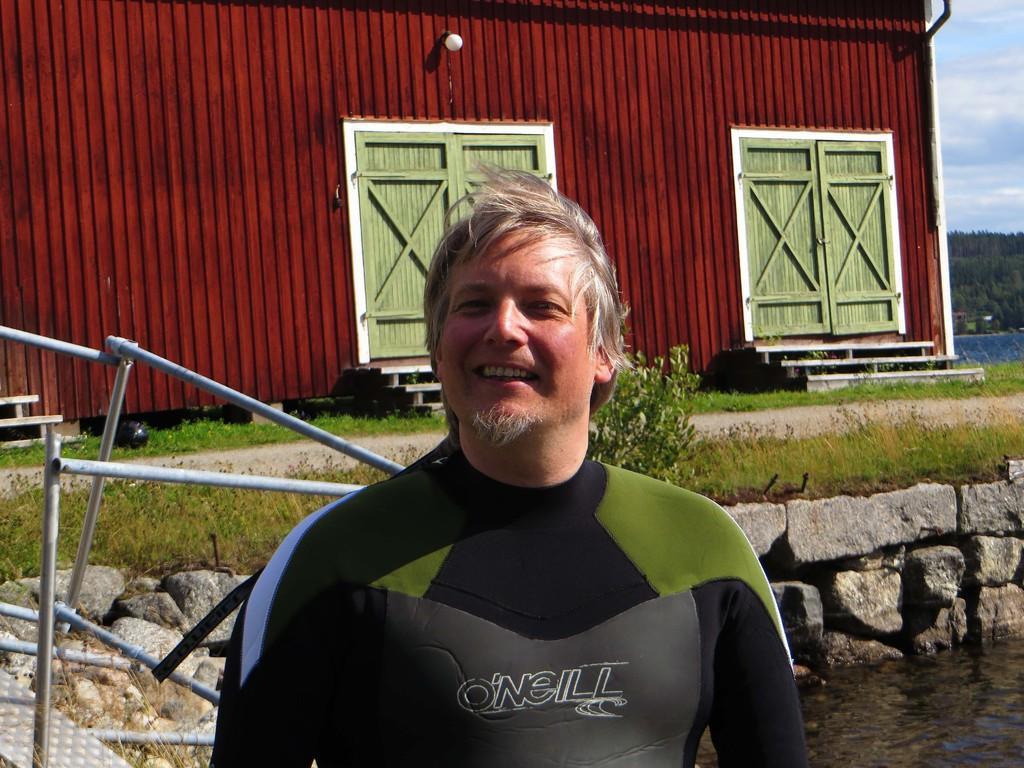How would you summarize this image in a sentence or two? In the middle of the image there is a man smiling. Behind him there are rods and also there is water. Behind the water there is a stone wall. Above that there is grass and also there is a plant. And also there is a road. In the background there is a wall with doors, steps and a lamp. On the right side corner of the image there are trees and also there is sky with clouds. 